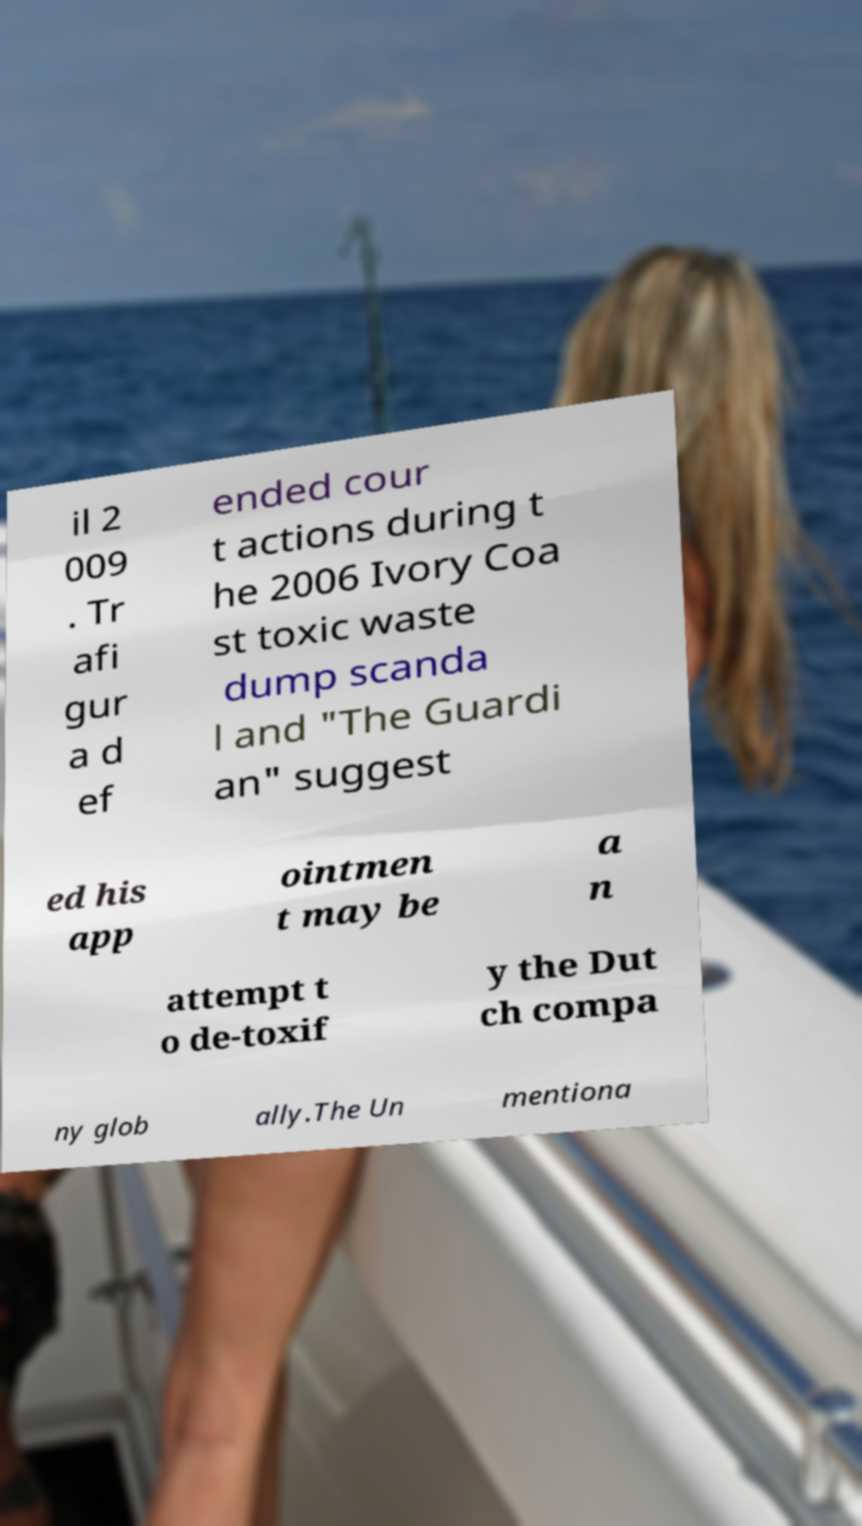There's text embedded in this image that I need extracted. Can you transcribe it verbatim? il 2 009 . Tr afi gur a d ef ended cour t actions during t he 2006 Ivory Coa st toxic waste dump scanda l and "The Guardi an" suggest ed his app ointmen t may be a n attempt t o de-toxif y the Dut ch compa ny glob ally.The Un mentiona 